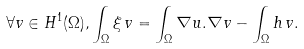<formula> <loc_0><loc_0><loc_500><loc_500>\forall v \in H ^ { 1 } ( \Omega ) , \int _ { \Omega } \xi \, v = \int _ { \Omega } \nabla u . \nabla v - \int _ { \Omega } h \, v .</formula> 